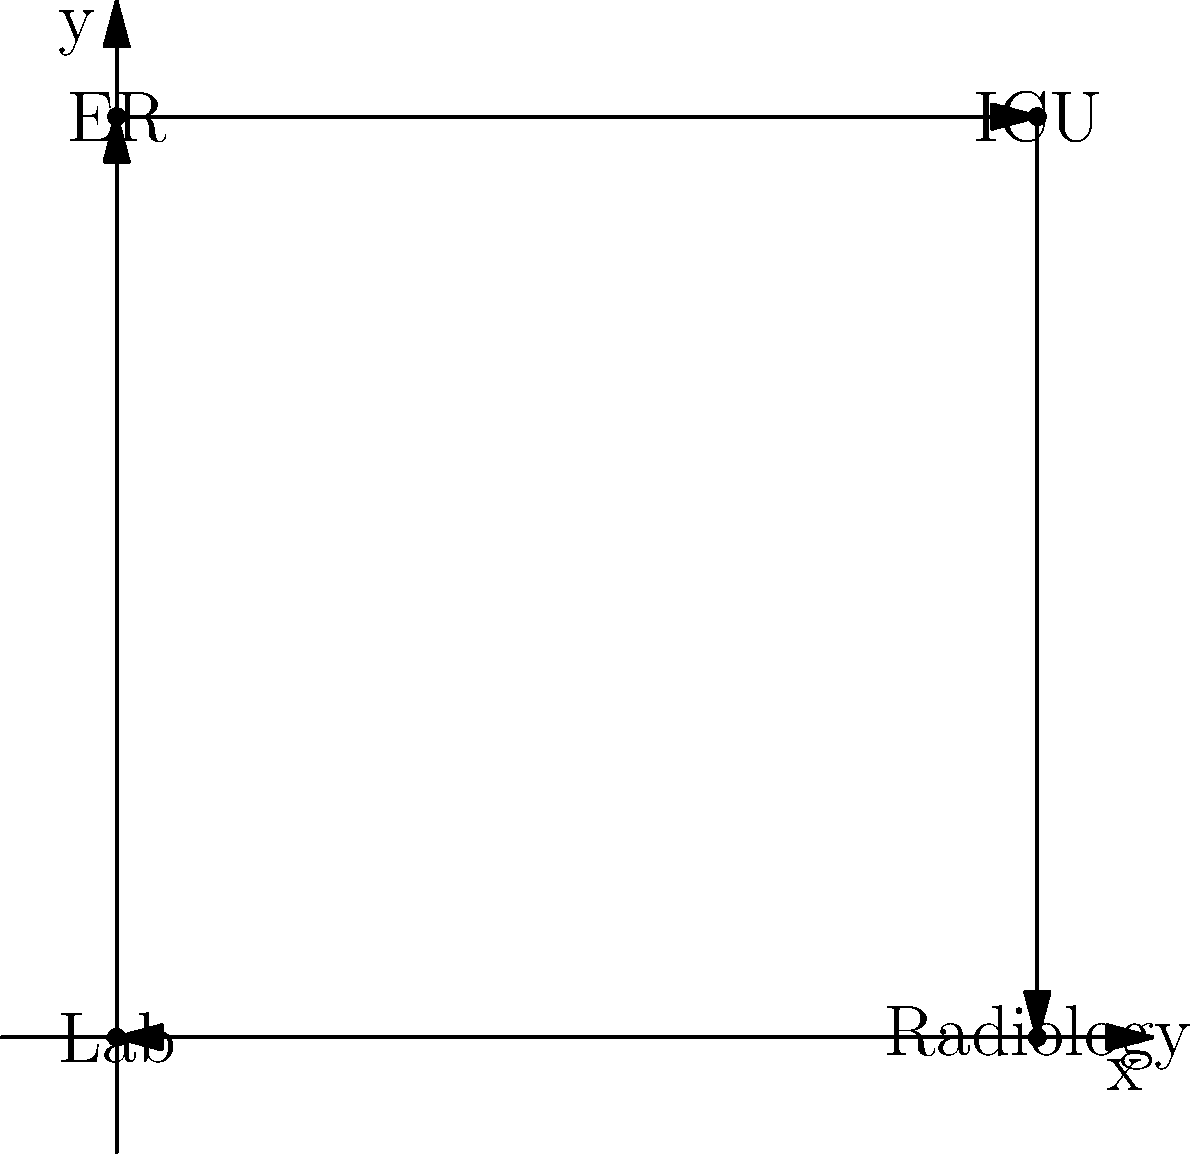Given the vector representation of hospital departments, where ER = (0,4), ICU = (4,4), Lab = (0,0), and Radiology = (4,0), calculate the total distance a patient needs to travel if they move from ER to ICU, then to Radiology, and finally to the Lab. Assume the distance between adjacent grid points is 1 unit. To solve this problem, we need to calculate the distance between each pair of departments in the given order and sum them up. Let's break it down step by step:

1. ER to ICU:
   Vector: (4,4) - (0,4) = (4,0)
   Distance: $\sqrt{4^2 + 0^2} = 4$ units

2. ICU to Radiology:
   Vector: (4,0) - (4,4) = (0,-4)
   Distance: $\sqrt{0^2 + (-4)^2} = 4$ units

3. Radiology to Lab:
   Vector: (0,0) - (4,0) = (-4,0)
   Distance: $\sqrt{(-4)^2 + 0^2} = 4$ units

Total distance:
$4 + 4 + 4 = 12$ units

This approach using vector representations allows for quick calculation of distances between departments, which is crucial for optimizing patient flow in a hospital setting.
Answer: 12 units 